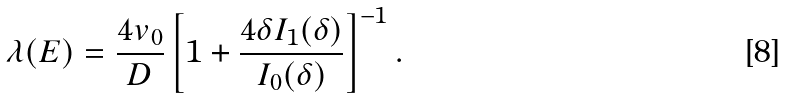Convert formula to latex. <formula><loc_0><loc_0><loc_500><loc_500>\lambda ( E ) = \frac { 4 v _ { 0 } } { D } \left [ 1 + \frac { 4 \delta I _ { 1 } ( \delta ) } { I _ { 0 } ( \delta ) } \right ] ^ { - 1 } .</formula> 